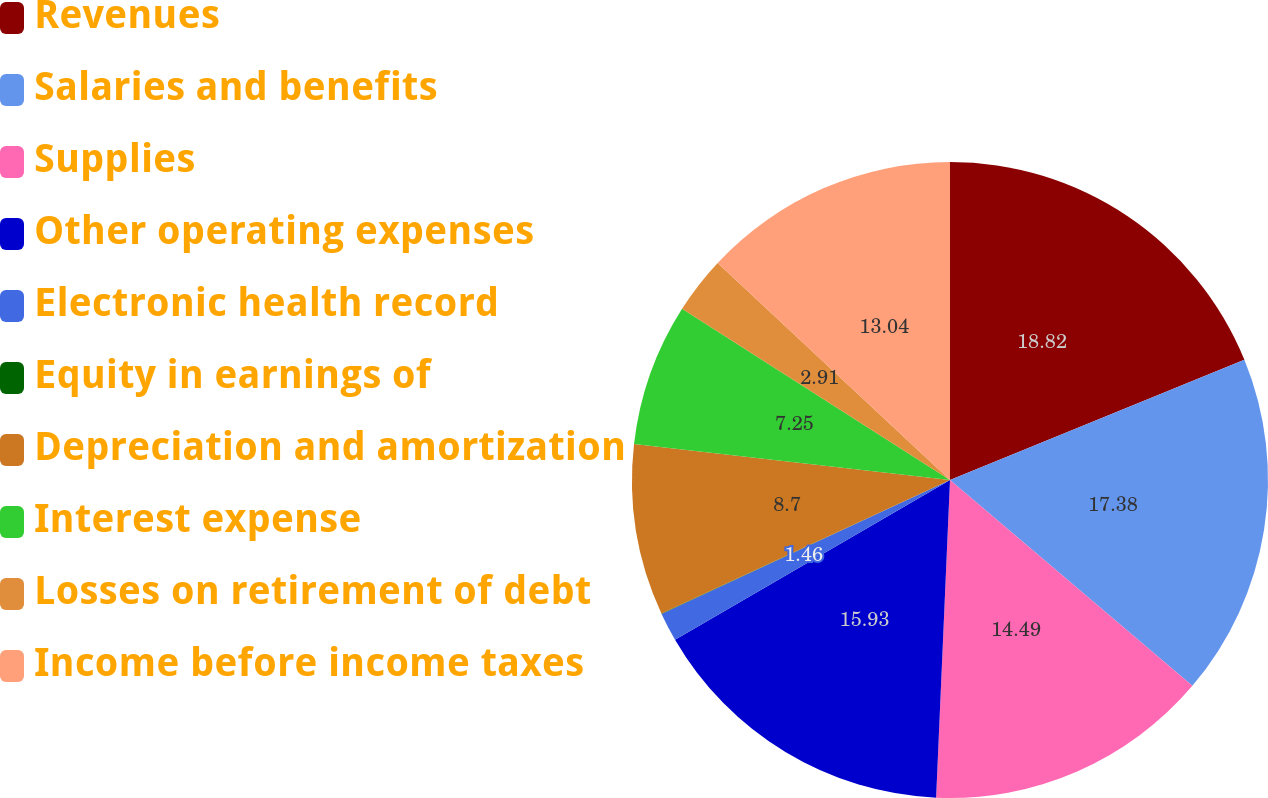<chart> <loc_0><loc_0><loc_500><loc_500><pie_chart><fcel>Revenues<fcel>Salaries and benefits<fcel>Supplies<fcel>Other operating expenses<fcel>Electronic health record<fcel>Equity in earnings of<fcel>Depreciation and amortization<fcel>Interest expense<fcel>Losses on retirement of debt<fcel>Income before income taxes<nl><fcel>18.83%<fcel>17.38%<fcel>14.49%<fcel>15.93%<fcel>1.46%<fcel>0.02%<fcel>8.7%<fcel>7.25%<fcel>2.91%<fcel>13.04%<nl></chart> 